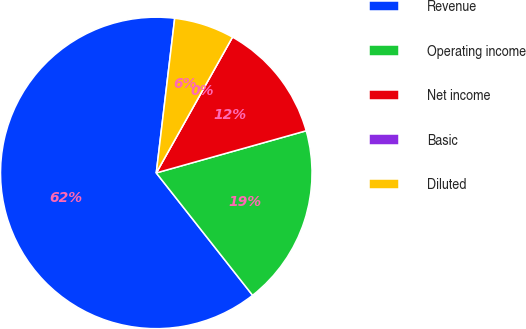Convert chart to OTSL. <chart><loc_0><loc_0><loc_500><loc_500><pie_chart><fcel>Revenue<fcel>Operating income<fcel>Net income<fcel>Basic<fcel>Diluted<nl><fcel>62.5%<fcel>18.75%<fcel>12.5%<fcel>0.0%<fcel>6.25%<nl></chart> 